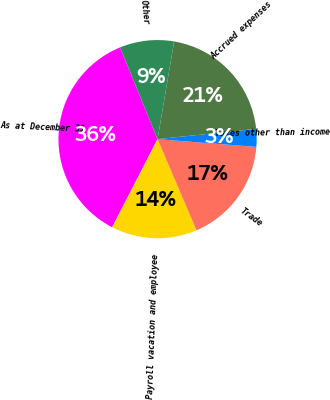Convert chart. <chart><loc_0><loc_0><loc_500><loc_500><pie_chart><fcel>As at December 31<fcel>Payroll vacation and employee<fcel>Trade<fcel>Taxes other than income<fcel>Accrued expenses<fcel>Other<nl><fcel>36.26%<fcel>13.99%<fcel>17.33%<fcel>2.9%<fcel>20.67%<fcel>8.85%<nl></chart> 